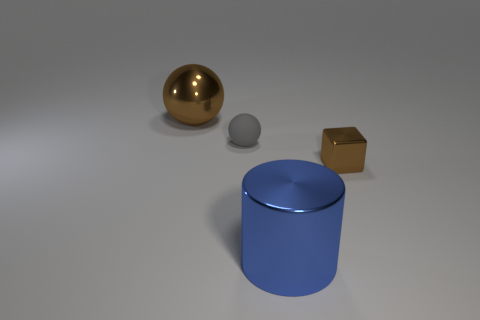What is the shape of the thing that is right of the small sphere and behind the large cylinder? The shape positioned to the right of the small sphere and behind the large cylinder is a cube. It has a distinct golden hue and its visible faces are squares, which are congruent with one another—a characteristic of a cube. 